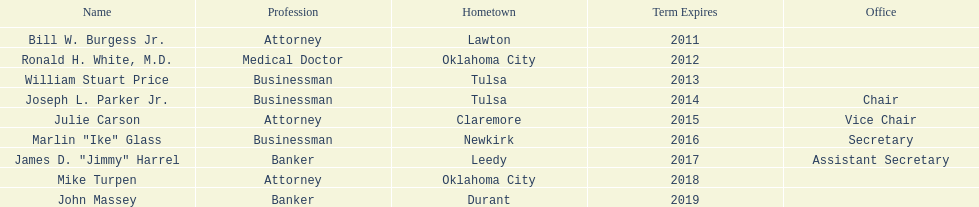What are all of the names? Bill W. Burgess Jr., Ronald H. White, M.D., William Stuart Price, Joseph L. Parker Jr., Julie Carson, Marlin "Ike" Glass, James D. "Jimmy" Harrel, Mike Turpen, John Massey. Where is each member from? Lawton, Oklahoma City, Tulsa, Tulsa, Claremore, Newkirk, Leedy, Oklahoma City, Durant. Along with joseph l. parker jr., which other member is from tulsa? William Stuart Price. 